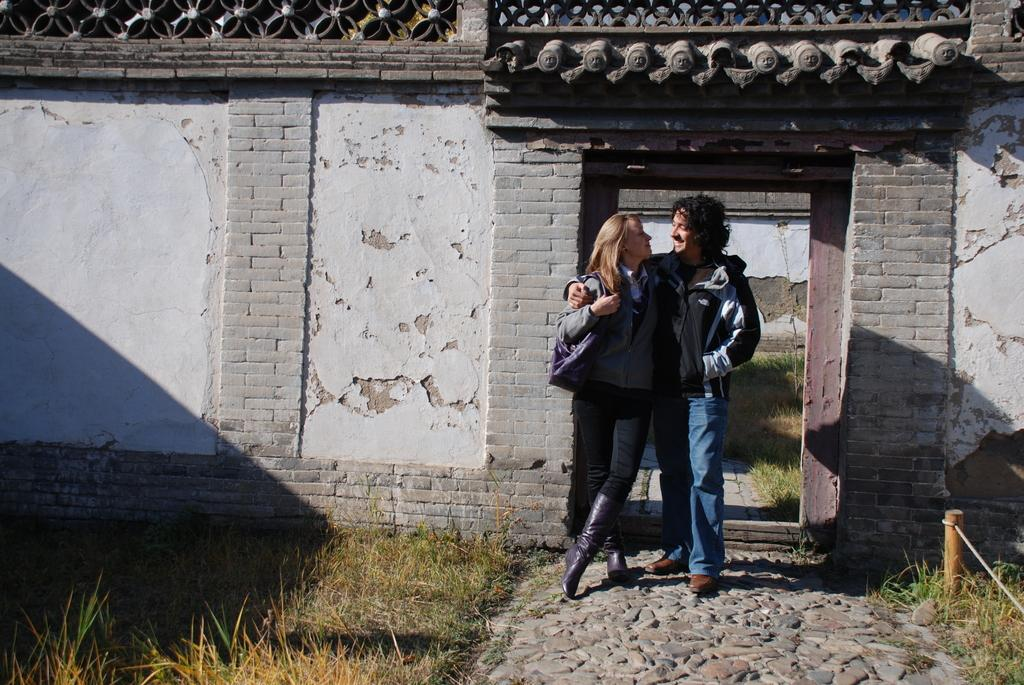What type of vegetation is present in the image? There is grass in the image. How many people are in the image? There are two persons in the image. What are the persons wearing? The persons are wearing clothes. What is behind the persons in the image? The persons are standing in front of a wall. What type of account does the wall in the image represent? The image does not depict an account; it shows grass, two persons, and a wall. What kind of amusement can be seen in the image? There is no amusement depicted in the image; it shows grass, two persons, and a wall. 